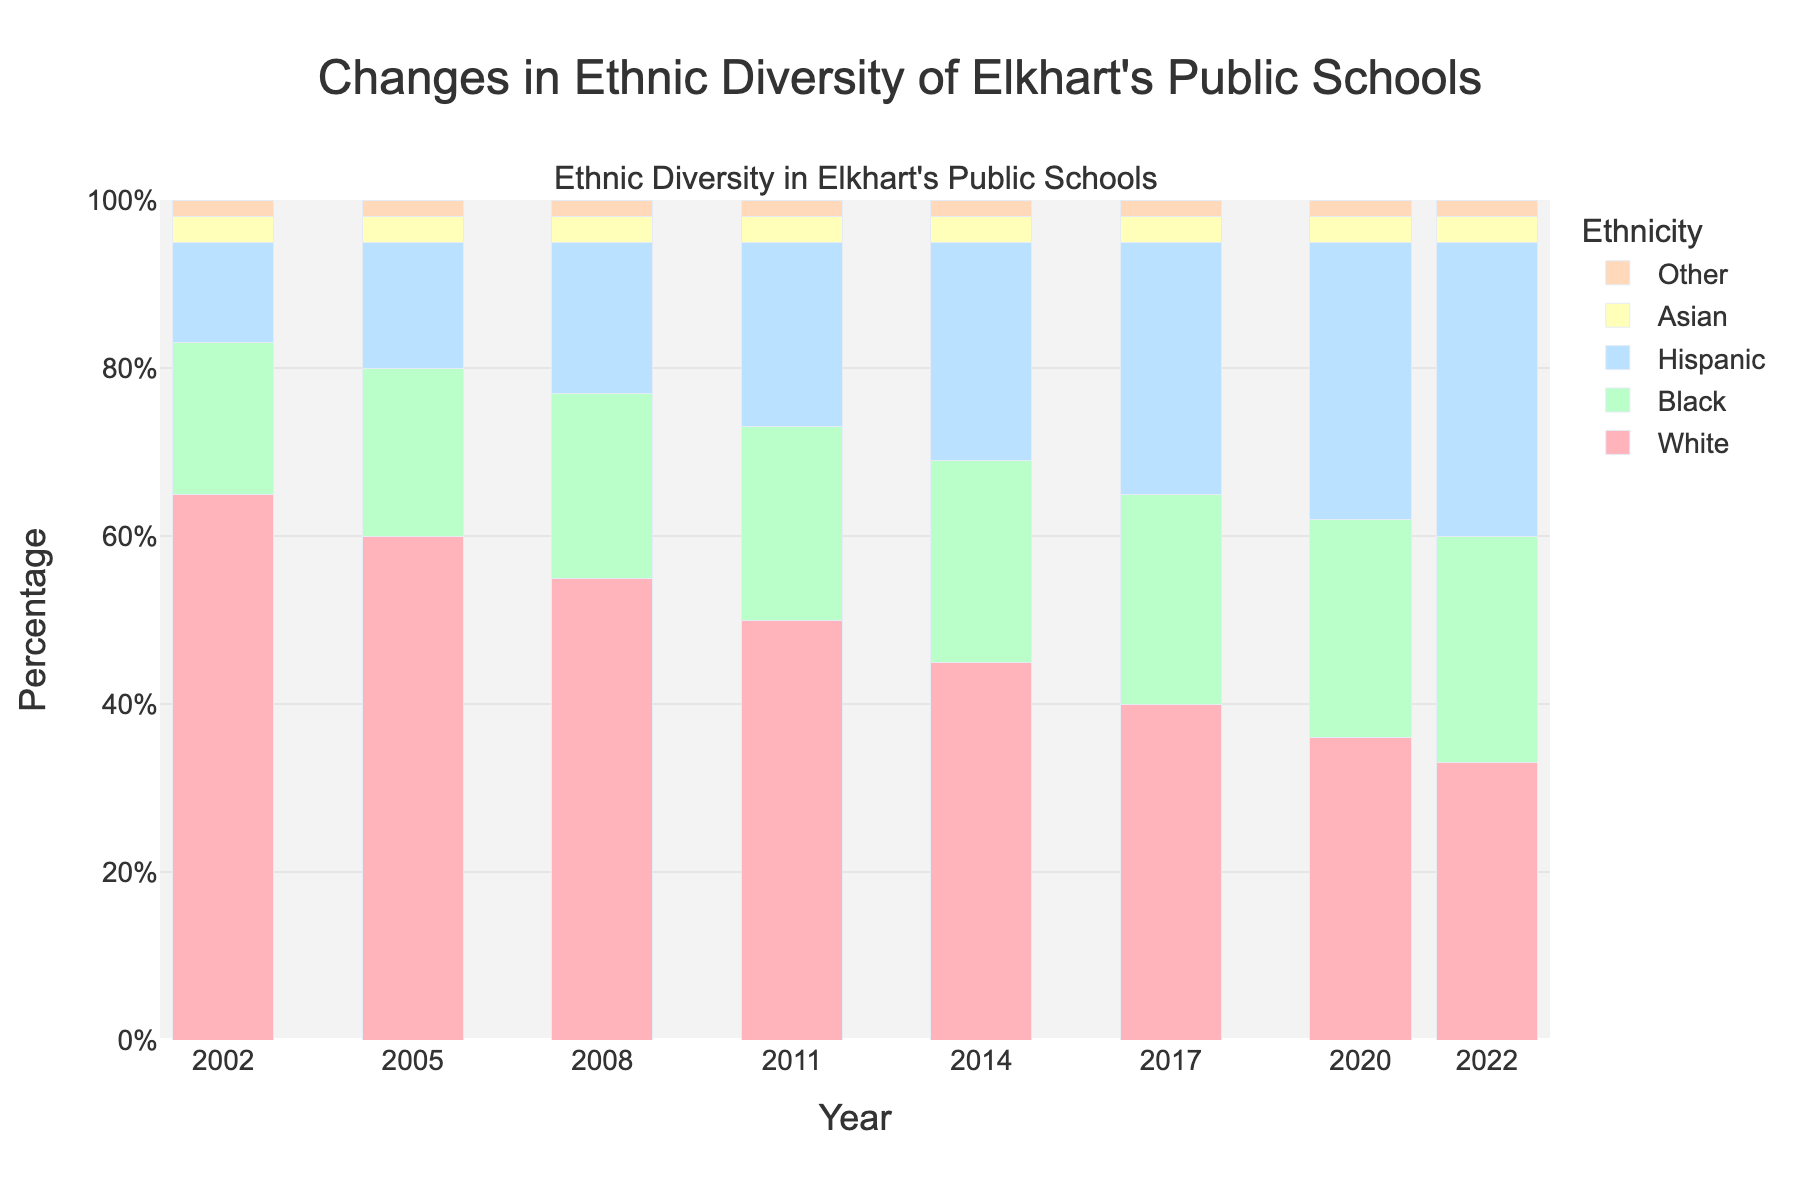What is the percentage of Hispanic students in 2014? In the year 2014, locate the bar representing Hispanic students on the stacked bar for that year, which indicates 26%.
Answer: 26% Which ethnicity had the highest percentage in 2002? Look at the bars for the year 2002, the tallest bar represents White students with 65%.
Answer: White How do the percentages of Black and Hispanic students compare in 2022? Compare the heights of the bars for Black and Hispanic students in 2022, Black is 27% and Hispanic is 35%.
Answer: Hispanic > Black What trend can be observed about the percentage of White students from 2002 to 2022? By observing the bars representing White students over the years 2002 to 2022, they decrease from 65% to 33%.
Answer: Decreasing What is the combined percentage of Black and Hispanic students in 2020? For the year 2020, add the percentages of Black (26%) and Hispanic (33%) students: 26 + 33 = 59%.
Answer: 59% Which ethnicity shows the smallest change in percentage over the years? Comparing the bars for each ethnicity from 2002 to 2022, Asian and Other both barely change.
Answer: Asian or Other What is the difference in the percentage of White students between 2002 and 2022? Subtract the percentage of White students in 2022 (33%) from that in 2002 (65%): 65 - 33 = 32%.
Answer: 32% Which ethnic group shows an increase in percentage each year? By observing the trend for each ethnic group, the Hispanic group shows a consistent increase from 12% in 2002 to 35% in 2022.
Answer: Hispanic By how much did the percentage of Black students change from 2011 to 2017? Subtract the percentage of Black students in 2011 (23%) from that in 2017 (25%): 25 - 23 = 2%.
Answer: 2% What is the percentage difference between Asian and Other students overall? Observe that both Asian and Other percentages remain consistent at 3% and 2% respectively, meaning the difference is 1%.
Answer: 1% 